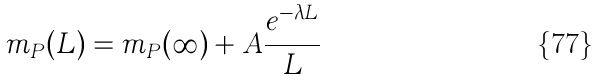<formula> <loc_0><loc_0><loc_500><loc_500>m _ { P } ( L ) = m _ { P } ( \infty ) + A \frac { e ^ { - \lambda L } } { L }</formula> 